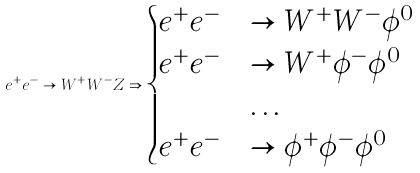<formula> <loc_0><loc_0><loc_500><loc_500>e ^ { + } e ^ { - } \to W ^ { + } W ^ { - } Z \Rightarrow \begin{cases} e ^ { + } e ^ { - } & \to W ^ { + } W ^ { - } \phi ^ { 0 } \\ e ^ { + } e ^ { - } & \to W ^ { + } \phi ^ { - } \phi ^ { 0 } \\ & \dots \\ e ^ { + } e ^ { - } & \to \phi ^ { + } \phi ^ { - } \phi ^ { 0 } \end{cases}</formula> 